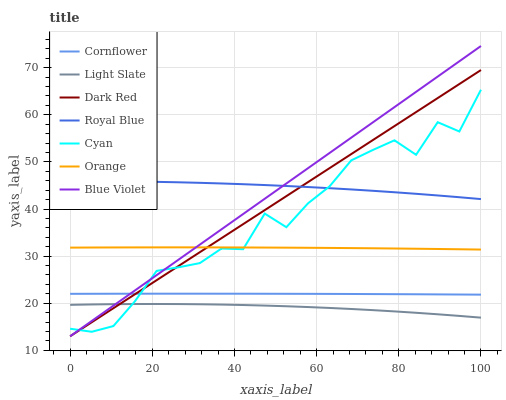Does Light Slate have the minimum area under the curve?
Answer yes or no. Yes. Does Royal Blue have the maximum area under the curve?
Answer yes or no. Yes. Does Dark Red have the minimum area under the curve?
Answer yes or no. No. Does Dark Red have the maximum area under the curve?
Answer yes or no. No. Is Dark Red the smoothest?
Answer yes or no. Yes. Is Cyan the roughest?
Answer yes or no. Yes. Is Light Slate the smoothest?
Answer yes or no. No. Is Light Slate the roughest?
Answer yes or no. No. Does Dark Red have the lowest value?
Answer yes or no. Yes. Does Light Slate have the lowest value?
Answer yes or no. No. Does Blue Violet have the highest value?
Answer yes or no. Yes. Does Dark Red have the highest value?
Answer yes or no. No. Is Orange less than Royal Blue?
Answer yes or no. Yes. Is Royal Blue greater than Orange?
Answer yes or no. Yes. Does Blue Violet intersect Cyan?
Answer yes or no. Yes. Is Blue Violet less than Cyan?
Answer yes or no. No. Is Blue Violet greater than Cyan?
Answer yes or no. No. Does Orange intersect Royal Blue?
Answer yes or no. No. 